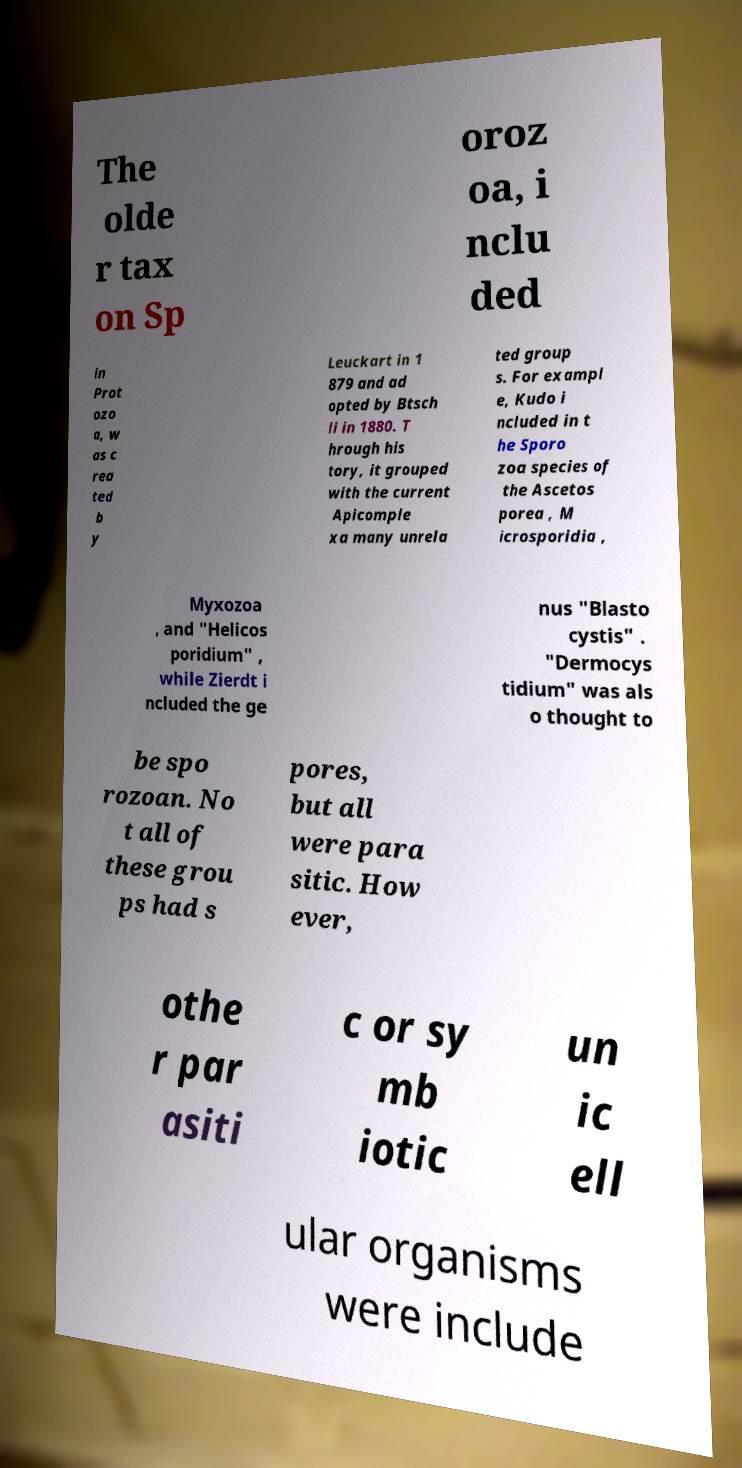Please read and relay the text visible in this image. What does it say? The olde r tax on Sp oroz oa, i nclu ded in Prot ozo a, w as c rea ted b y Leuckart in 1 879 and ad opted by Btsch li in 1880. T hrough his tory, it grouped with the current Apicomple xa many unrela ted group s. For exampl e, Kudo i ncluded in t he Sporo zoa species of the Ascetos porea , M icrosporidia , Myxozoa , and "Helicos poridium" , while Zierdt i ncluded the ge nus "Blasto cystis" . "Dermocys tidium" was als o thought to be spo rozoan. No t all of these grou ps had s pores, but all were para sitic. How ever, othe r par asiti c or sy mb iotic un ic ell ular organisms were include 